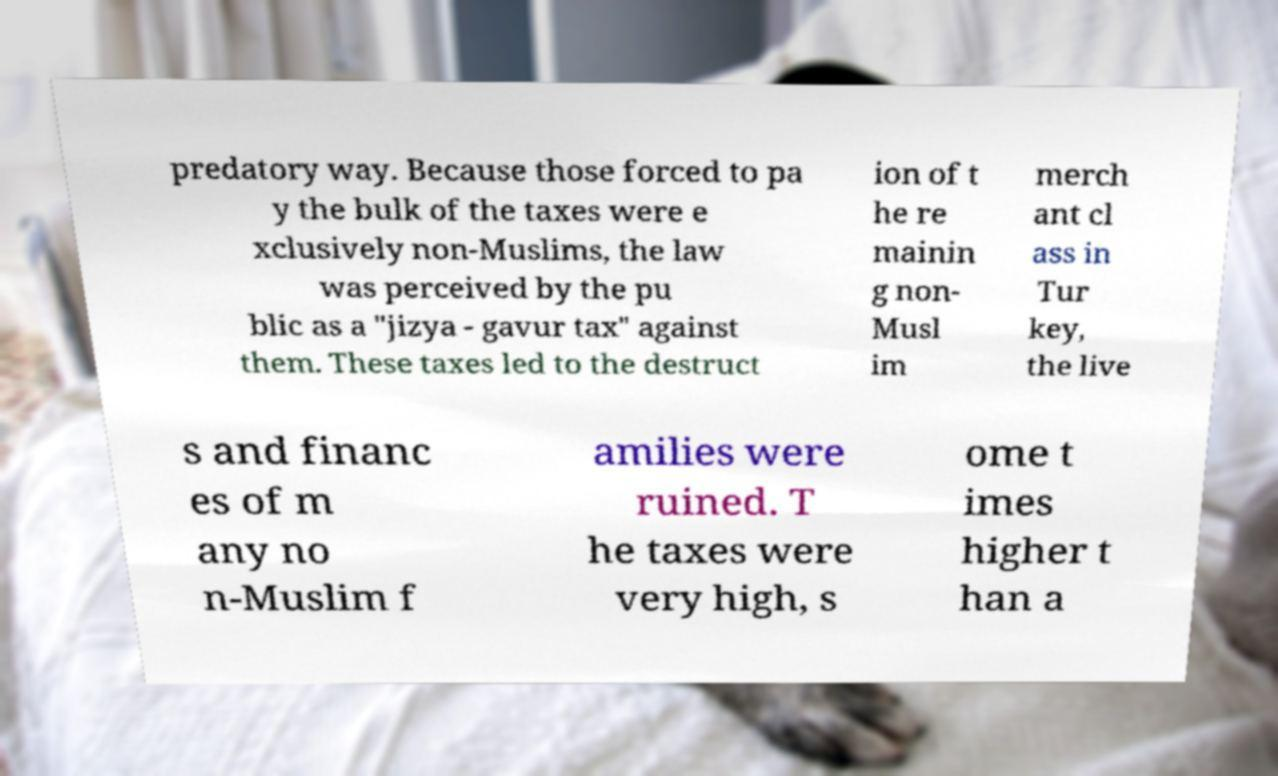Could you extract and type out the text from this image? predatory way. Because those forced to pa y the bulk of the taxes were e xclusively non-Muslims, the law was perceived by the pu blic as a "jizya - gavur tax" against them. These taxes led to the destruct ion of t he re mainin g non- Musl im merch ant cl ass in Tur key, the live s and financ es of m any no n-Muslim f amilies were ruined. T he taxes were very high, s ome t imes higher t han a 